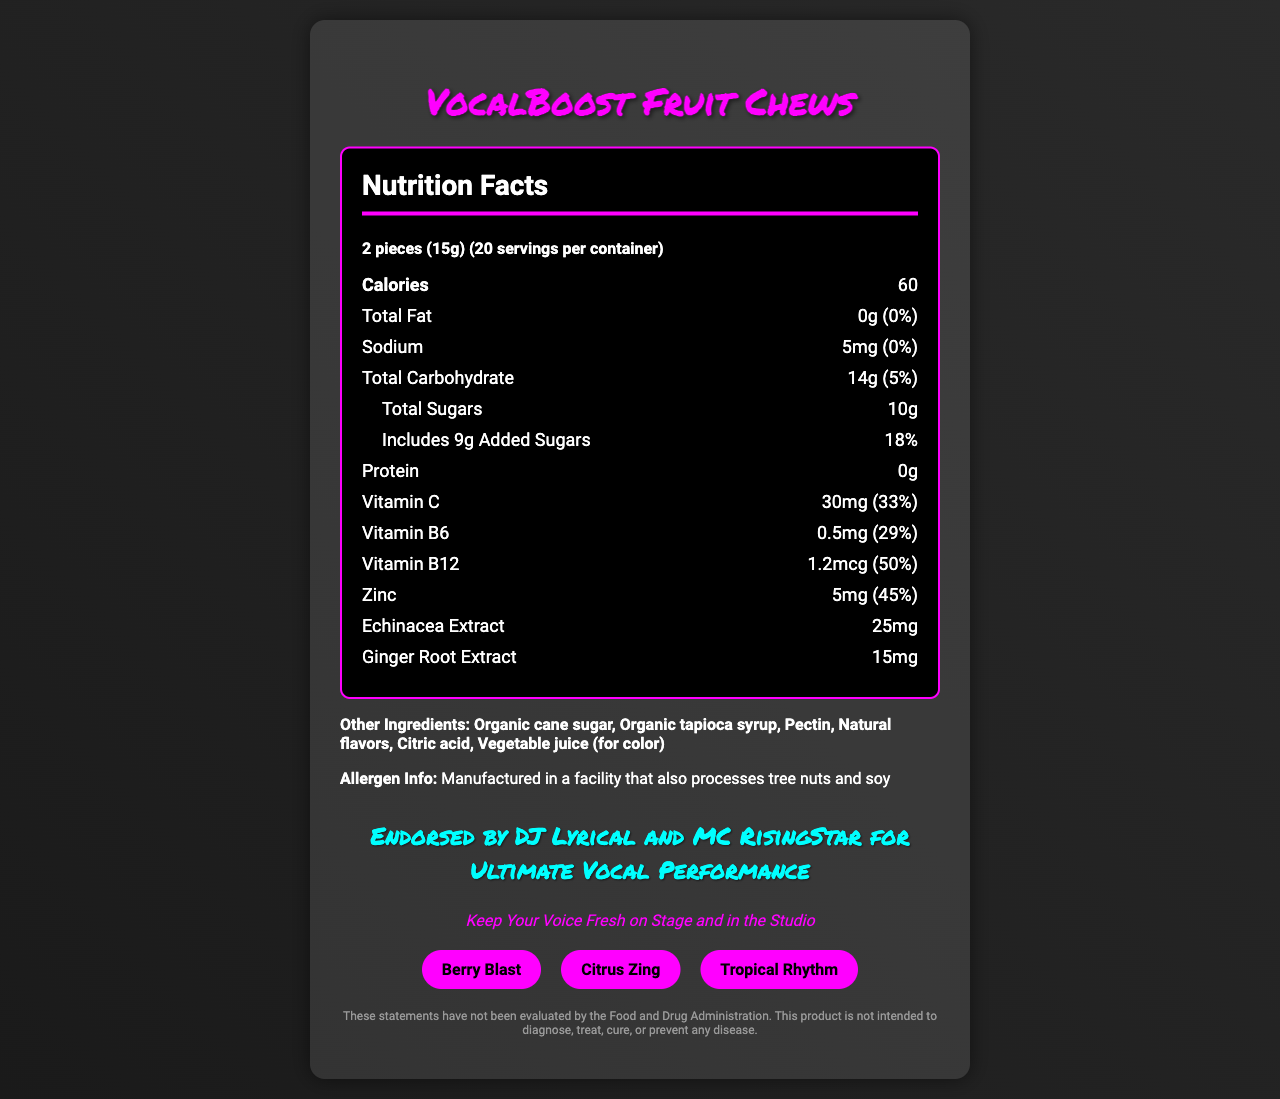what is the serving size? The serving size is clearly mentioned at the top of the document under "Nutrition Facts".
Answer: 2 pieces (15g) How many calories are in one serving? The calorie content per serving is listed as 60 calories.
Answer: 60 What is the amount of total sugars per serving? The document states that total sugars per serving amount to 10 grams.
Answer: 10g How much Vitamin C is in one serving? The amount of Vitamin C per serving is listed as 30 milligrams.
Answer: 30mg Which vitamins are included in the VocalBoost Fruit Chews? The document lists Vitamin C, Vitamin B6, and Vitamin B12 in the nutrition facts section.
Answer: Vitamin C, Vitamin B6, Vitamin B12 Which of the following is NOT a flavor of VocalBoost Fruit Chews? A. Berry Blast B. Citrus Zing C. Mango Tango D. Tropical Rhythm The flavors listed are Berry Blast, Citrus Zing, and Tropical Rhythm. Mango Tango is not mentioned.
Answer: C. Mango Tango What is the daily value percentage of Vitamin B12 per serving? A. 29% B. 33% C. 45% D. 50% The Vitamin B12 daily value percentage is stated as 50%.
Answer: D. 50% Is there any protein in the VocalBoost Fruit Chews? The amount of protein per serving is listed as 0g, indicating there is no protein in the product.
Answer: No Are the VocalBoost Fruit Chews free from tree nuts? The allergen information states that the product is manufactured in a facility that also processes tree nuts.
Answer: No Summarize the main idea of the document. This document presents the nutritional details of VocalBoost Fruit Chews, highlights the vitamins and extracts included for vocal health, lists flavors, and provides allergen information and endorsements from popular hip-hop artists.
Answer: VocalBoost Fruit Chews are vitamin-infused candies endorsed by DJ Lyrical and MC RisingStar to support vocal health. They come in various flavors and contain essential vitamins like Vitamin C, B6, B12, as well as zinc, echinacea extract, and ginger root extract. The product is marketed to keep your voice fresh on stage and in the studio. What is the source of color in the candy? The other ingredients section lists vegetable juice as the source for color.
Answer: Vegetable juice Can the document verify FDA evaluations of the product? The disclaimer explicitly states that the statements have not been evaluated by the Food and Drug Administration.
Answer: No How many added sugars are there per serving? The amount of added sugars included in the total sugars is indicated as 9g.
Answer: 9g What extracts are included in the ingredients? The document lists Echinacea extract and Ginger root extract in the nutrition facts section.
Answer: Echinacea extract, Ginger root extract What are the main ingredients of VocalBoost Fruit Chews? The other ingredients section lists these as the main components of the candy.
Answer: Organic cane sugar, Organic tapioca syrup, Pectin, Natural flavors, Citric acid, Vegetable juice (for color) 